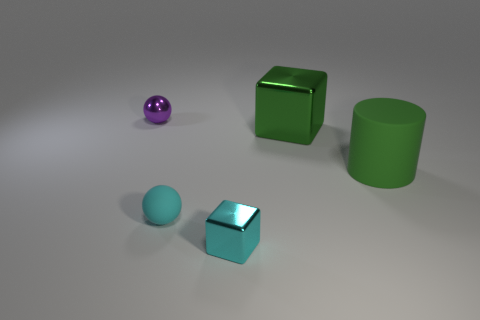Is the color of the large object that is to the left of the large green rubber cylinder the same as the big object right of the green metal block?
Make the answer very short. Yes. Is the number of cyan objects that are on the right side of the tiny rubber ball the same as the number of large brown rubber things?
Ensure brevity in your answer.  No. There is a rubber sphere; what number of tiny shiny spheres are to the right of it?
Give a very brief answer. 0. What size is the cyan sphere?
Offer a very short reply. Small. What is the color of the sphere that is made of the same material as the green cylinder?
Keep it short and to the point. Cyan. How many other cyan rubber balls have the same size as the cyan matte sphere?
Your answer should be compact. 0. Are the big green thing behind the big green cylinder and the big cylinder made of the same material?
Offer a terse response. No. Is the number of tiny objects that are in front of the cyan sphere less than the number of small cyan matte spheres?
Offer a very short reply. No. What shape is the small metal object that is behind the small cyan block?
Keep it short and to the point. Sphere. The purple shiny object that is the same size as the matte sphere is what shape?
Offer a terse response. Sphere. 